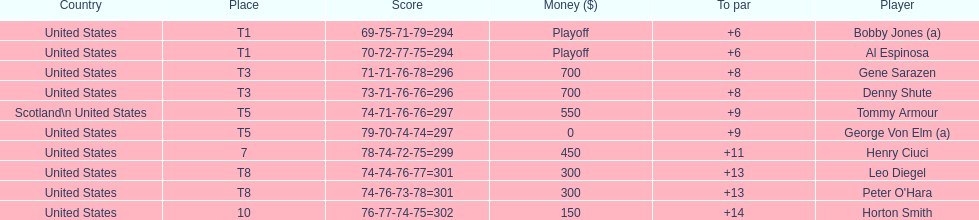How many players represented scotland? 1. 